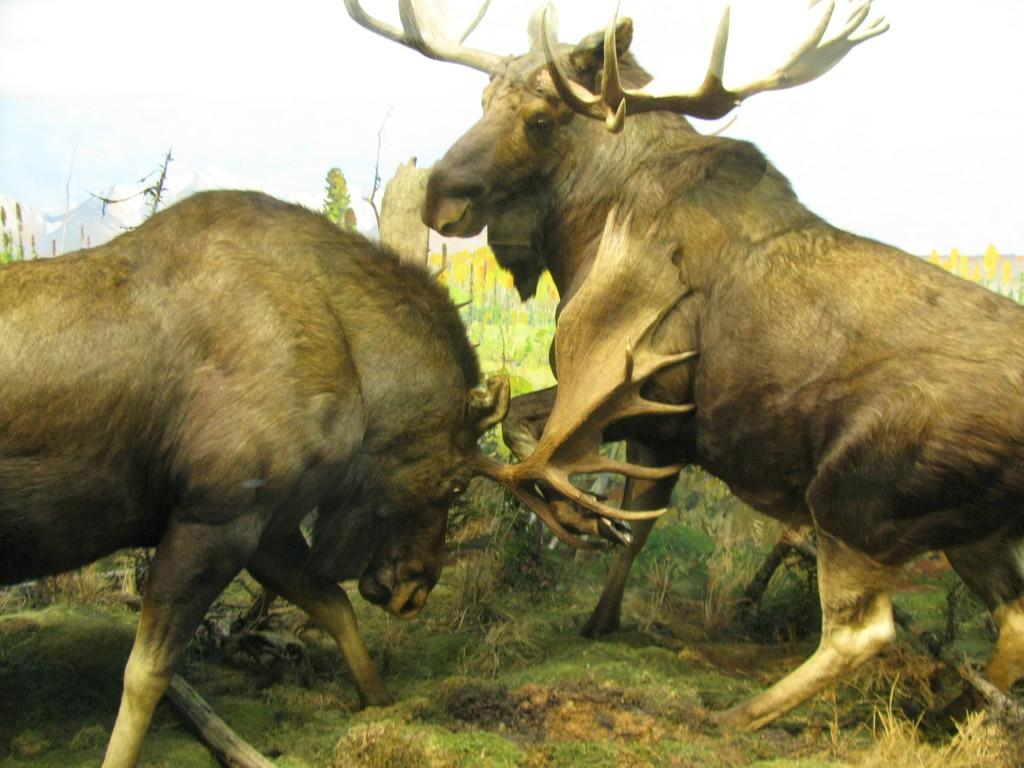What types of living organisms are present in the image? There are animals in the image. What are the animals doing in the image? The animals are fighting with each other. What type of hair can be seen on the animals in the image? There is no information about the animals' hair in the image, so it cannot be determined from the picture. 